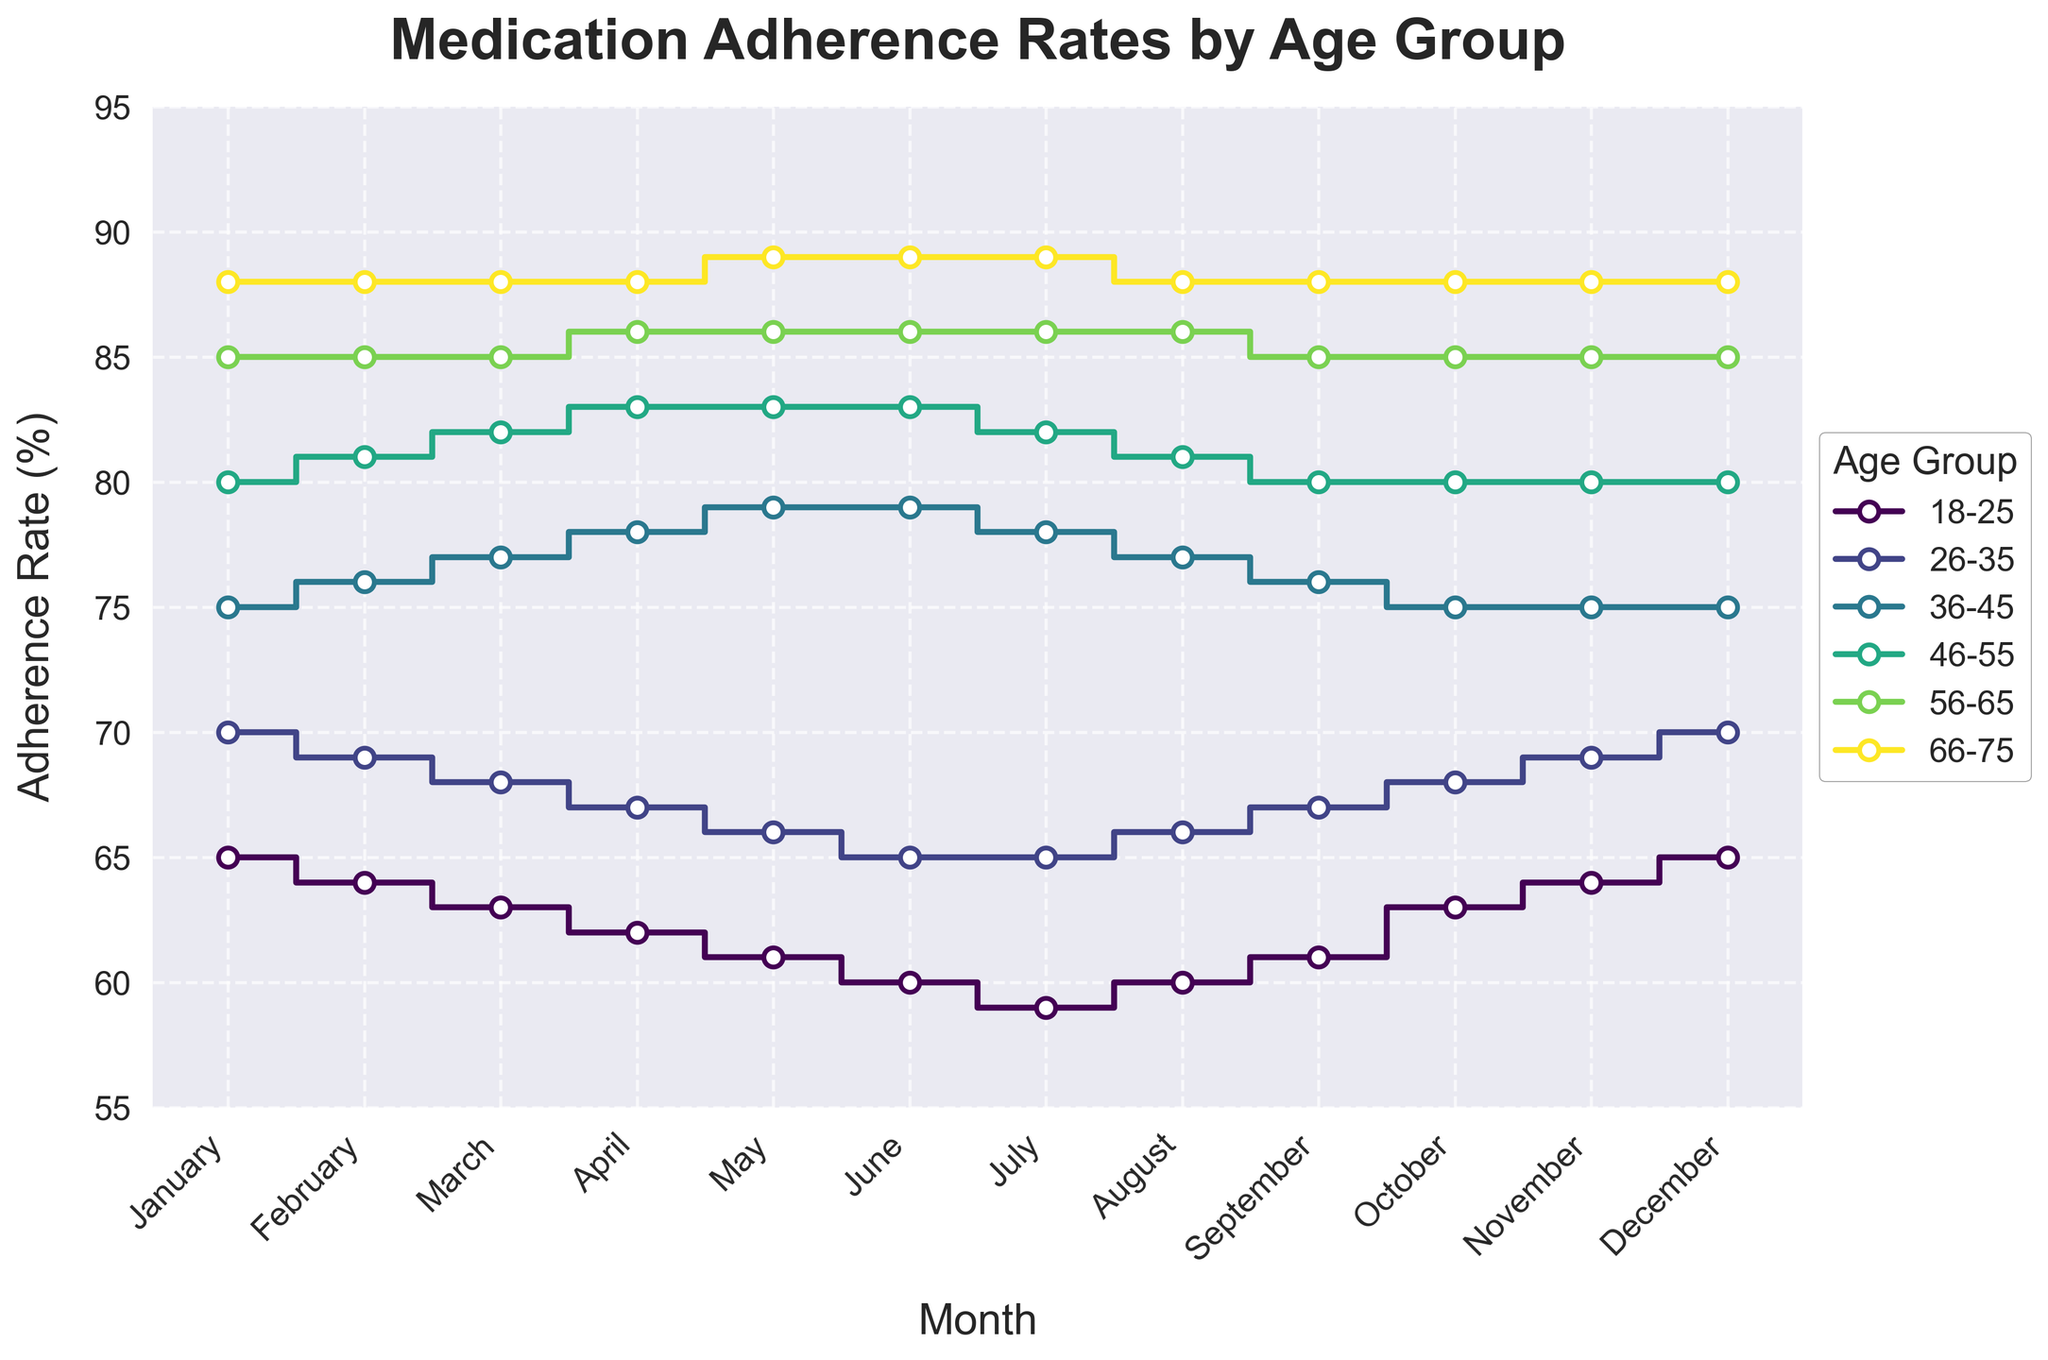What's the title of the figure? The title is typically placed at the top of the plot. In this case, it reads "Medication Adherence Rates by Age Group".
Answer: Medication Adherence Rates by Age Group Which age group has the highest adherence rate in January? The January adherence rates can be compared across age groups by referring to the markers. The 66-75 age group shows the highest adherence rate at 88%.
Answer: 66-75 How does the adherence rate for the 18-25 age group change from January to December? The adherence rate for the 18-25 age group starts at 65% in January, drops to a low of 59% in July, and then returns to 65% by December.
Answer: It fluctuates but ends back at 65% What is the average adherence rate for the 56-65 age group throughout the year? Adding up the monthly adherence rates for the 56-65 age group (85+85+85+86+86+86+86+86+85+85+85+85) and then dividing by 12 gives an average of 85.33%.
Answer: 85.33% Which age group shows the most stable adherence rate over the year? By looking for the least fluctuation in the adherence rates, the 66-75 age group shows minimal variation, mostly remaining at 88%, with a slight increase to 89% in May, June, and July.
Answer: 66-75 Between which months does the 36-45 age group experience a decline in adherence rate? Observing the plot, the adherence rate for the 36-45 age group rises until May (79%), stabilizes in June (79%), and then declines until it reaches 75% in December, starting noticeably in July.
Answer: July to December How does the adherence rate for the 46-55 age group vary between April and September? The adherence rate for the 46-55 age group increases from 83% in April to a peak of 83% in May and June, then decreases back down to 80% by September.
Answer: It first rises to 83%, then falls to 80% What is the range of adherence rates for the 26-35 age group over the year? The adherence rates for the 26-35 age group range from a low of 65% in June and July to a high of 70% in January and December. Subtracting the lowest from the highest gives the range of 5%.
Answer: 5% Which age group has an increasing trend in adherence rates up to mid-year but then decreases slightly? The 36-45 age group demonstrates this pattern, with adherence rates increasing until reaching May at 79%, stabilizing in June, and then gradually decreasing.
Answer: 36-45 